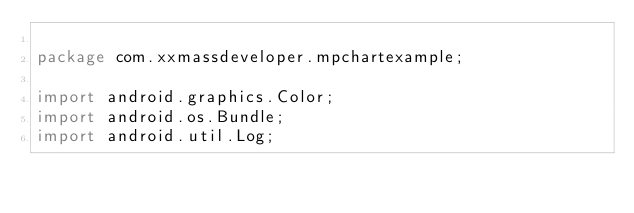<code> <loc_0><loc_0><loc_500><loc_500><_Java_>
package com.xxmassdeveloper.mpchartexample;

import android.graphics.Color;
import android.os.Bundle;
import android.util.Log;</code> 